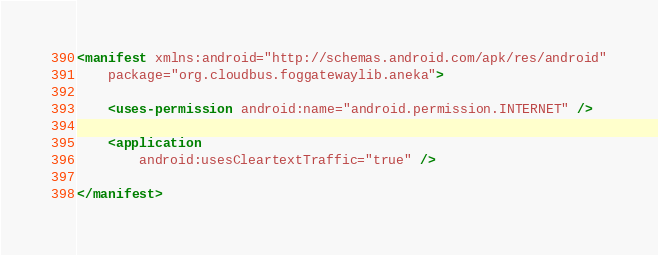<code> <loc_0><loc_0><loc_500><loc_500><_XML_><manifest xmlns:android="http://schemas.android.com/apk/res/android"
    package="org.cloudbus.foggatewaylib.aneka">

    <uses-permission android:name="android.permission.INTERNET" />

    <application
        android:usesCleartextTraffic="true" />

</manifest></code> 